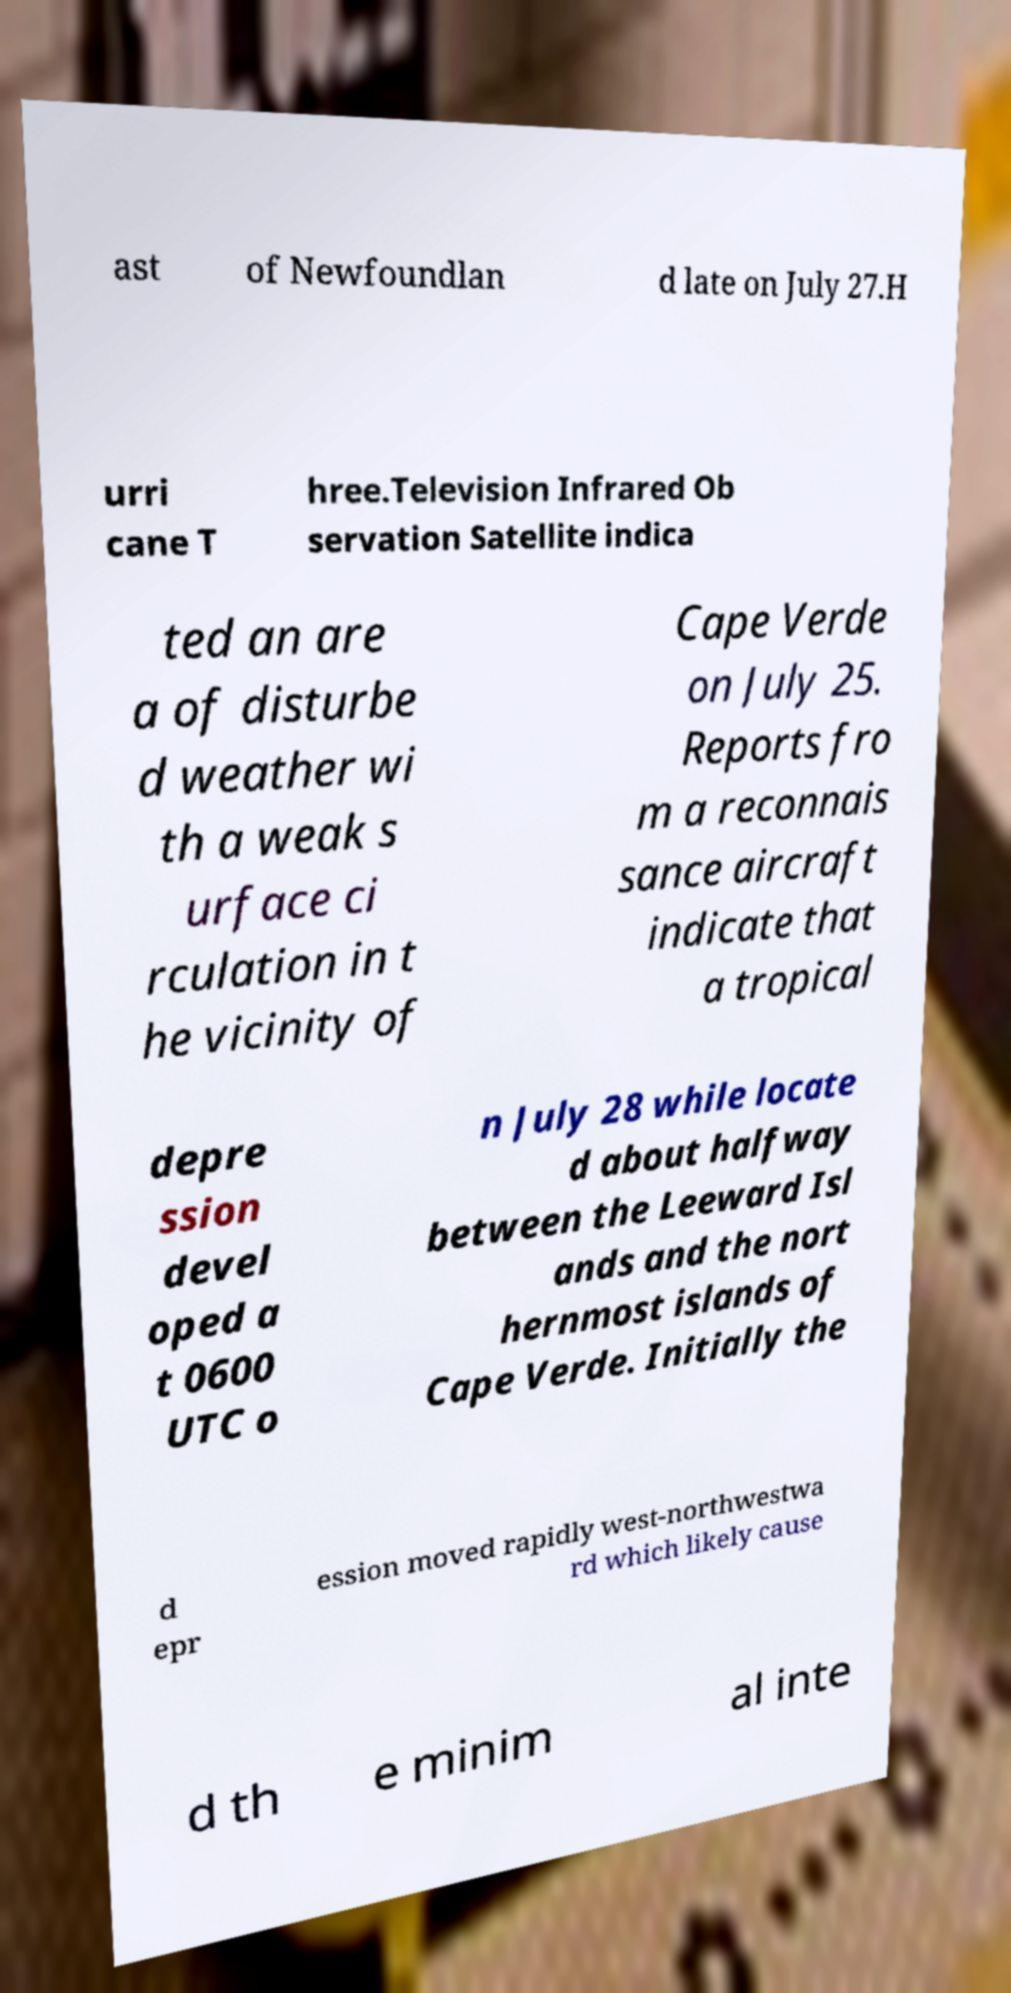Could you extract and type out the text from this image? ast of Newfoundlan d late on July 27.H urri cane T hree.Television Infrared Ob servation Satellite indica ted an are a of disturbe d weather wi th a weak s urface ci rculation in t he vicinity of Cape Verde on July 25. Reports fro m a reconnais sance aircraft indicate that a tropical depre ssion devel oped a t 0600 UTC o n July 28 while locate d about halfway between the Leeward Isl ands and the nort hernmost islands of Cape Verde. Initially the d epr ession moved rapidly west-northwestwa rd which likely cause d th e minim al inte 